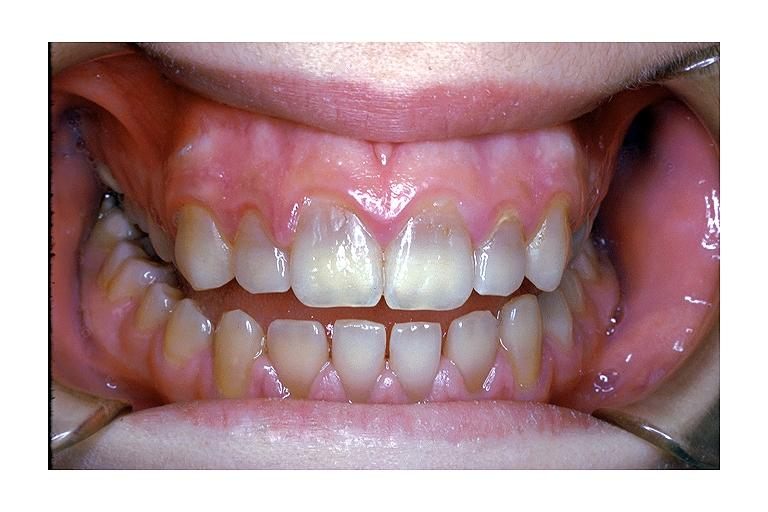does this image show tetracycline induced discoloration?
Answer the question using a single word or phrase. Yes 